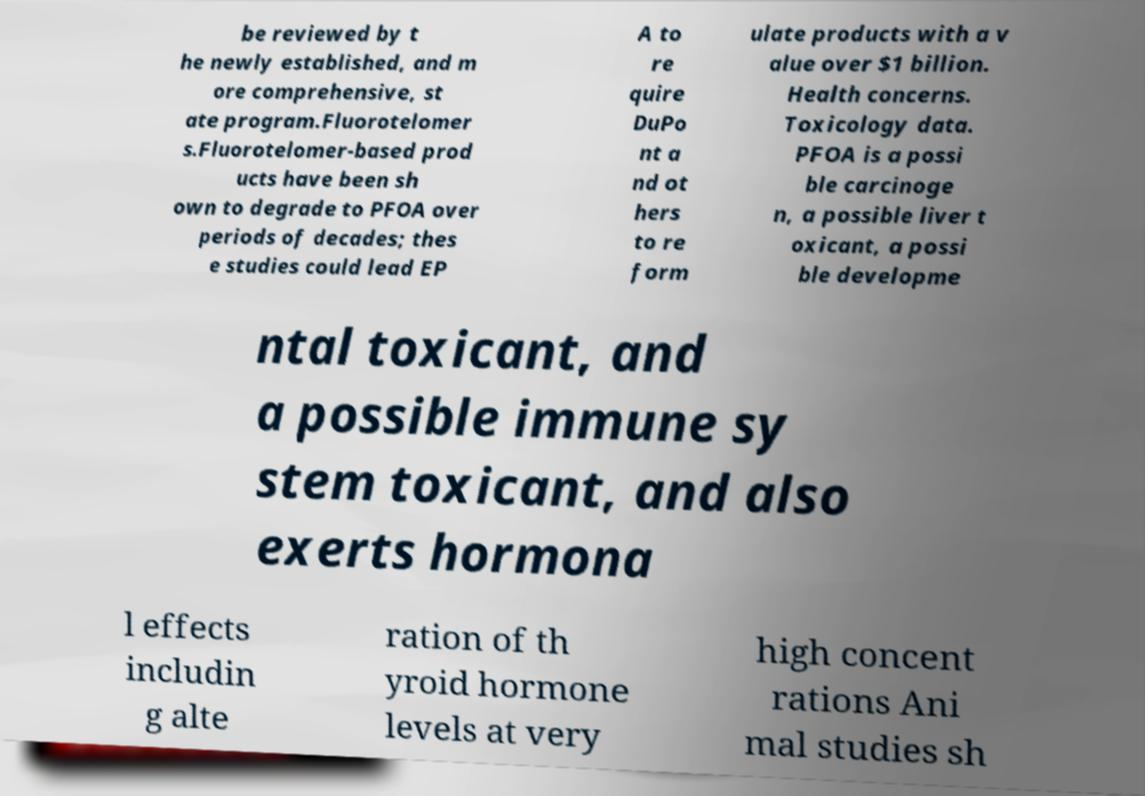Please identify and transcribe the text found in this image. be reviewed by t he newly established, and m ore comprehensive, st ate program.Fluorotelomer s.Fluorotelomer-based prod ucts have been sh own to degrade to PFOA over periods of decades; thes e studies could lead EP A to re quire DuPo nt a nd ot hers to re form ulate products with a v alue over $1 billion. Health concerns. Toxicology data. PFOA is a possi ble carcinoge n, a possible liver t oxicant, a possi ble developme ntal toxicant, and a possible immune sy stem toxicant, and also exerts hormona l effects includin g alte ration of th yroid hormone levels at very high concent rations Ani mal studies sh 